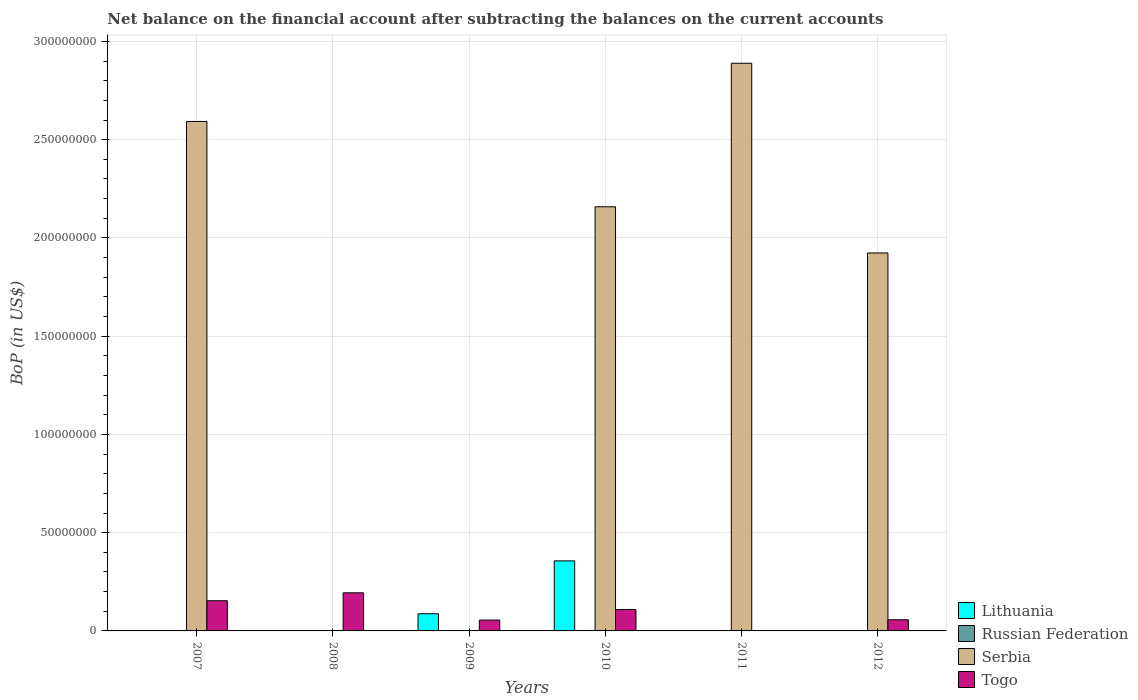How many different coloured bars are there?
Provide a short and direct response. 3. Are the number of bars per tick equal to the number of legend labels?
Your answer should be very brief. No. Are the number of bars on each tick of the X-axis equal?
Your answer should be compact. No. What is the label of the 4th group of bars from the left?
Your answer should be compact. 2010. What is the Balance of Payments in Serbia in 2010?
Your answer should be very brief. 2.16e+08. Across all years, what is the maximum Balance of Payments in Lithuania?
Offer a terse response. 3.56e+07. What is the total Balance of Payments in Lithuania in the graph?
Provide a short and direct response. 4.44e+07. What is the difference between the Balance of Payments in Togo in 2008 and that in 2012?
Your answer should be very brief. 1.37e+07. What is the difference between the Balance of Payments in Lithuania in 2011 and the Balance of Payments in Serbia in 2008?
Ensure brevity in your answer.  0. In the year 2010, what is the difference between the Balance of Payments in Serbia and Balance of Payments in Togo?
Provide a short and direct response. 2.05e+08. What is the ratio of the Balance of Payments in Lithuania in 2009 to that in 2010?
Provide a short and direct response. 0.25. Is the Balance of Payments in Serbia in 2010 less than that in 2011?
Provide a short and direct response. Yes. Is the difference between the Balance of Payments in Serbia in 2010 and 2012 greater than the difference between the Balance of Payments in Togo in 2010 and 2012?
Make the answer very short. Yes. What is the difference between the highest and the second highest Balance of Payments in Togo?
Your answer should be compact. 4.04e+06. What is the difference between the highest and the lowest Balance of Payments in Serbia?
Offer a terse response. 2.89e+08. In how many years, is the Balance of Payments in Togo greater than the average Balance of Payments in Togo taken over all years?
Keep it short and to the point. 3. Is it the case that in every year, the sum of the Balance of Payments in Togo and Balance of Payments in Lithuania is greater than the sum of Balance of Payments in Russian Federation and Balance of Payments in Serbia?
Make the answer very short. No. Are all the bars in the graph horizontal?
Provide a succinct answer. No. Are the values on the major ticks of Y-axis written in scientific E-notation?
Your answer should be compact. No. Does the graph contain any zero values?
Offer a terse response. Yes. Where does the legend appear in the graph?
Provide a succinct answer. Bottom right. How many legend labels are there?
Make the answer very short. 4. What is the title of the graph?
Your answer should be very brief. Net balance on the financial account after subtracting the balances on the current accounts. What is the label or title of the Y-axis?
Your answer should be compact. BoP (in US$). What is the BoP (in US$) in Serbia in 2007?
Offer a terse response. 2.59e+08. What is the BoP (in US$) of Togo in 2007?
Give a very brief answer. 1.54e+07. What is the BoP (in US$) in Russian Federation in 2008?
Ensure brevity in your answer.  0. What is the BoP (in US$) of Serbia in 2008?
Your response must be concise. 0. What is the BoP (in US$) of Togo in 2008?
Keep it short and to the point. 1.94e+07. What is the BoP (in US$) in Lithuania in 2009?
Your answer should be compact. 8.75e+06. What is the BoP (in US$) in Russian Federation in 2009?
Your answer should be compact. 0. What is the BoP (in US$) in Serbia in 2009?
Keep it short and to the point. 0. What is the BoP (in US$) in Togo in 2009?
Your response must be concise. 5.51e+06. What is the BoP (in US$) in Lithuania in 2010?
Your response must be concise. 3.56e+07. What is the BoP (in US$) of Russian Federation in 2010?
Your answer should be compact. 0. What is the BoP (in US$) of Serbia in 2010?
Offer a very short reply. 2.16e+08. What is the BoP (in US$) in Togo in 2010?
Your answer should be very brief. 1.09e+07. What is the BoP (in US$) of Russian Federation in 2011?
Your answer should be compact. 0. What is the BoP (in US$) of Serbia in 2011?
Provide a succinct answer. 2.89e+08. What is the BoP (in US$) in Russian Federation in 2012?
Ensure brevity in your answer.  0. What is the BoP (in US$) of Serbia in 2012?
Offer a very short reply. 1.92e+08. What is the BoP (in US$) of Togo in 2012?
Your answer should be very brief. 5.67e+06. Across all years, what is the maximum BoP (in US$) of Lithuania?
Keep it short and to the point. 3.56e+07. Across all years, what is the maximum BoP (in US$) in Serbia?
Make the answer very short. 2.89e+08. Across all years, what is the maximum BoP (in US$) in Togo?
Keep it short and to the point. 1.94e+07. Across all years, what is the minimum BoP (in US$) in Togo?
Make the answer very short. 0. What is the total BoP (in US$) of Lithuania in the graph?
Your answer should be very brief. 4.44e+07. What is the total BoP (in US$) of Russian Federation in the graph?
Your answer should be very brief. 0. What is the total BoP (in US$) in Serbia in the graph?
Offer a terse response. 9.56e+08. What is the total BoP (in US$) in Togo in the graph?
Keep it short and to the point. 5.68e+07. What is the difference between the BoP (in US$) of Togo in 2007 and that in 2008?
Offer a terse response. -4.04e+06. What is the difference between the BoP (in US$) in Togo in 2007 and that in 2009?
Your answer should be very brief. 9.85e+06. What is the difference between the BoP (in US$) of Serbia in 2007 and that in 2010?
Keep it short and to the point. 4.34e+07. What is the difference between the BoP (in US$) in Togo in 2007 and that in 2010?
Give a very brief answer. 4.47e+06. What is the difference between the BoP (in US$) of Serbia in 2007 and that in 2011?
Offer a very short reply. -2.96e+07. What is the difference between the BoP (in US$) in Serbia in 2007 and that in 2012?
Offer a very short reply. 6.69e+07. What is the difference between the BoP (in US$) in Togo in 2007 and that in 2012?
Provide a short and direct response. 9.69e+06. What is the difference between the BoP (in US$) of Togo in 2008 and that in 2009?
Your response must be concise. 1.39e+07. What is the difference between the BoP (in US$) of Togo in 2008 and that in 2010?
Provide a succinct answer. 8.51e+06. What is the difference between the BoP (in US$) in Togo in 2008 and that in 2012?
Your answer should be very brief. 1.37e+07. What is the difference between the BoP (in US$) of Lithuania in 2009 and that in 2010?
Offer a terse response. -2.69e+07. What is the difference between the BoP (in US$) in Togo in 2009 and that in 2010?
Your answer should be very brief. -5.38e+06. What is the difference between the BoP (in US$) of Togo in 2009 and that in 2012?
Provide a short and direct response. -1.60e+05. What is the difference between the BoP (in US$) in Serbia in 2010 and that in 2011?
Your response must be concise. -7.30e+07. What is the difference between the BoP (in US$) in Serbia in 2010 and that in 2012?
Your answer should be compact. 2.35e+07. What is the difference between the BoP (in US$) of Togo in 2010 and that in 2012?
Make the answer very short. 5.22e+06. What is the difference between the BoP (in US$) in Serbia in 2011 and that in 2012?
Make the answer very short. 9.65e+07. What is the difference between the BoP (in US$) of Serbia in 2007 and the BoP (in US$) of Togo in 2008?
Give a very brief answer. 2.40e+08. What is the difference between the BoP (in US$) in Serbia in 2007 and the BoP (in US$) in Togo in 2009?
Offer a very short reply. 2.54e+08. What is the difference between the BoP (in US$) of Serbia in 2007 and the BoP (in US$) of Togo in 2010?
Offer a very short reply. 2.48e+08. What is the difference between the BoP (in US$) in Serbia in 2007 and the BoP (in US$) in Togo in 2012?
Your answer should be very brief. 2.54e+08. What is the difference between the BoP (in US$) in Lithuania in 2009 and the BoP (in US$) in Serbia in 2010?
Your answer should be very brief. -2.07e+08. What is the difference between the BoP (in US$) in Lithuania in 2009 and the BoP (in US$) in Togo in 2010?
Make the answer very short. -2.14e+06. What is the difference between the BoP (in US$) of Lithuania in 2009 and the BoP (in US$) of Serbia in 2011?
Provide a succinct answer. -2.80e+08. What is the difference between the BoP (in US$) in Lithuania in 2009 and the BoP (in US$) in Serbia in 2012?
Offer a very short reply. -1.84e+08. What is the difference between the BoP (in US$) of Lithuania in 2009 and the BoP (in US$) of Togo in 2012?
Provide a succinct answer. 3.07e+06. What is the difference between the BoP (in US$) in Lithuania in 2010 and the BoP (in US$) in Serbia in 2011?
Your response must be concise. -2.53e+08. What is the difference between the BoP (in US$) in Lithuania in 2010 and the BoP (in US$) in Serbia in 2012?
Ensure brevity in your answer.  -1.57e+08. What is the difference between the BoP (in US$) in Lithuania in 2010 and the BoP (in US$) in Togo in 2012?
Ensure brevity in your answer.  3.00e+07. What is the difference between the BoP (in US$) of Serbia in 2010 and the BoP (in US$) of Togo in 2012?
Your answer should be compact. 2.10e+08. What is the difference between the BoP (in US$) in Serbia in 2011 and the BoP (in US$) in Togo in 2012?
Your answer should be very brief. 2.83e+08. What is the average BoP (in US$) in Lithuania per year?
Your response must be concise. 7.40e+06. What is the average BoP (in US$) of Russian Federation per year?
Give a very brief answer. 0. What is the average BoP (in US$) in Serbia per year?
Make the answer very short. 1.59e+08. What is the average BoP (in US$) of Togo per year?
Keep it short and to the point. 9.47e+06. In the year 2007, what is the difference between the BoP (in US$) in Serbia and BoP (in US$) in Togo?
Ensure brevity in your answer.  2.44e+08. In the year 2009, what is the difference between the BoP (in US$) in Lithuania and BoP (in US$) in Togo?
Provide a short and direct response. 3.23e+06. In the year 2010, what is the difference between the BoP (in US$) in Lithuania and BoP (in US$) in Serbia?
Your answer should be compact. -1.80e+08. In the year 2010, what is the difference between the BoP (in US$) of Lithuania and BoP (in US$) of Togo?
Keep it short and to the point. 2.47e+07. In the year 2010, what is the difference between the BoP (in US$) of Serbia and BoP (in US$) of Togo?
Give a very brief answer. 2.05e+08. In the year 2012, what is the difference between the BoP (in US$) of Serbia and BoP (in US$) of Togo?
Make the answer very short. 1.87e+08. What is the ratio of the BoP (in US$) in Togo in 2007 to that in 2008?
Offer a very short reply. 0.79. What is the ratio of the BoP (in US$) of Togo in 2007 to that in 2009?
Keep it short and to the point. 2.79. What is the ratio of the BoP (in US$) of Serbia in 2007 to that in 2010?
Your answer should be very brief. 1.2. What is the ratio of the BoP (in US$) in Togo in 2007 to that in 2010?
Keep it short and to the point. 1.41. What is the ratio of the BoP (in US$) in Serbia in 2007 to that in 2011?
Give a very brief answer. 0.9. What is the ratio of the BoP (in US$) in Serbia in 2007 to that in 2012?
Your response must be concise. 1.35. What is the ratio of the BoP (in US$) in Togo in 2007 to that in 2012?
Keep it short and to the point. 2.71. What is the ratio of the BoP (in US$) of Togo in 2008 to that in 2009?
Your answer should be compact. 3.52. What is the ratio of the BoP (in US$) in Togo in 2008 to that in 2010?
Your answer should be compact. 1.78. What is the ratio of the BoP (in US$) of Togo in 2008 to that in 2012?
Give a very brief answer. 3.42. What is the ratio of the BoP (in US$) of Lithuania in 2009 to that in 2010?
Give a very brief answer. 0.25. What is the ratio of the BoP (in US$) in Togo in 2009 to that in 2010?
Give a very brief answer. 0.51. What is the ratio of the BoP (in US$) of Togo in 2009 to that in 2012?
Give a very brief answer. 0.97. What is the ratio of the BoP (in US$) in Serbia in 2010 to that in 2011?
Your answer should be very brief. 0.75. What is the ratio of the BoP (in US$) in Serbia in 2010 to that in 2012?
Your response must be concise. 1.12. What is the ratio of the BoP (in US$) in Togo in 2010 to that in 2012?
Provide a succinct answer. 1.92. What is the ratio of the BoP (in US$) in Serbia in 2011 to that in 2012?
Your response must be concise. 1.5. What is the difference between the highest and the second highest BoP (in US$) in Serbia?
Provide a succinct answer. 2.96e+07. What is the difference between the highest and the second highest BoP (in US$) in Togo?
Offer a terse response. 4.04e+06. What is the difference between the highest and the lowest BoP (in US$) in Lithuania?
Your answer should be compact. 3.56e+07. What is the difference between the highest and the lowest BoP (in US$) in Serbia?
Provide a short and direct response. 2.89e+08. What is the difference between the highest and the lowest BoP (in US$) in Togo?
Your answer should be very brief. 1.94e+07. 